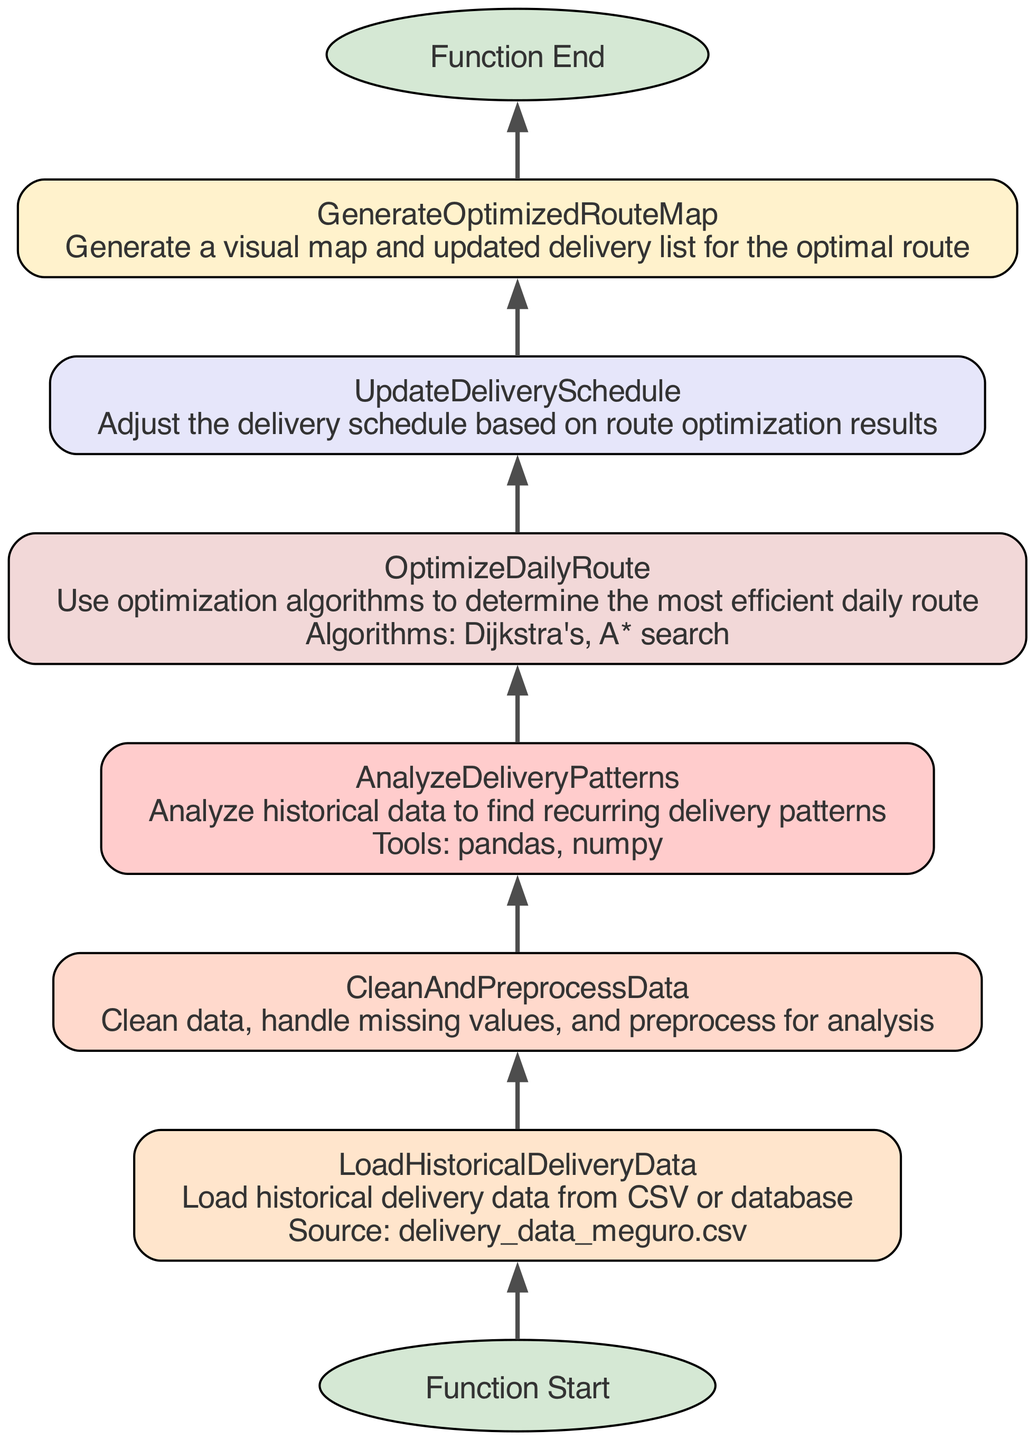What is the first step in the flowchart? The flowchart starts with the "Function Start" node, which marks the beginning of the process.
Answer: Function Start How many nodes are there in the flowchart? Counting each of the steps including the start and end nodes, there are a total of seven nodes in the diagram.
Answer: Seven Which step follows "AnalyzeDeliveryPatterns"? According to the diagram, the step that follows "AnalyzeDeliveryPatterns" is "OptimizeDailyRoute".
Answer: OptimizeDailyRoute What tools are mentioned for analyzing delivery patterns? The tools specified for analyzing delivery patterns are "pandas" and "numpy" as listed in the description of the "AnalyzeDeliveryPatterns" step.
Answer: pandas, numpy What is the last step before the function ends? The last step before reaching the end of the flowchart is "GenerateOptimizedRouteMap", which signifies the final action taken in the process.
Answer: GenerateOptimizedRouteMap How is the route optimization achieved according to the flowchart? The route optimization is achieved through the use of optimization algorithms, specifically "Dijkstra's" and "A* search" as indicated in the "OptimizeDailyRoute" step.
Answer: Dijkstra's, A* search Which step requires data cleaning? The node labeled "CleanAndPreprocessData" clearly describes the necessity of cleaning the data, thus that is the step that requires data cleaning.
Answer: CleanAndPreprocessData What does the "UpdateDeliverySchedule" step adjust? This step adjusts the delivery schedule based on the results produced from the route optimization conducted earlier in the process.
Answer: Delivery schedule 